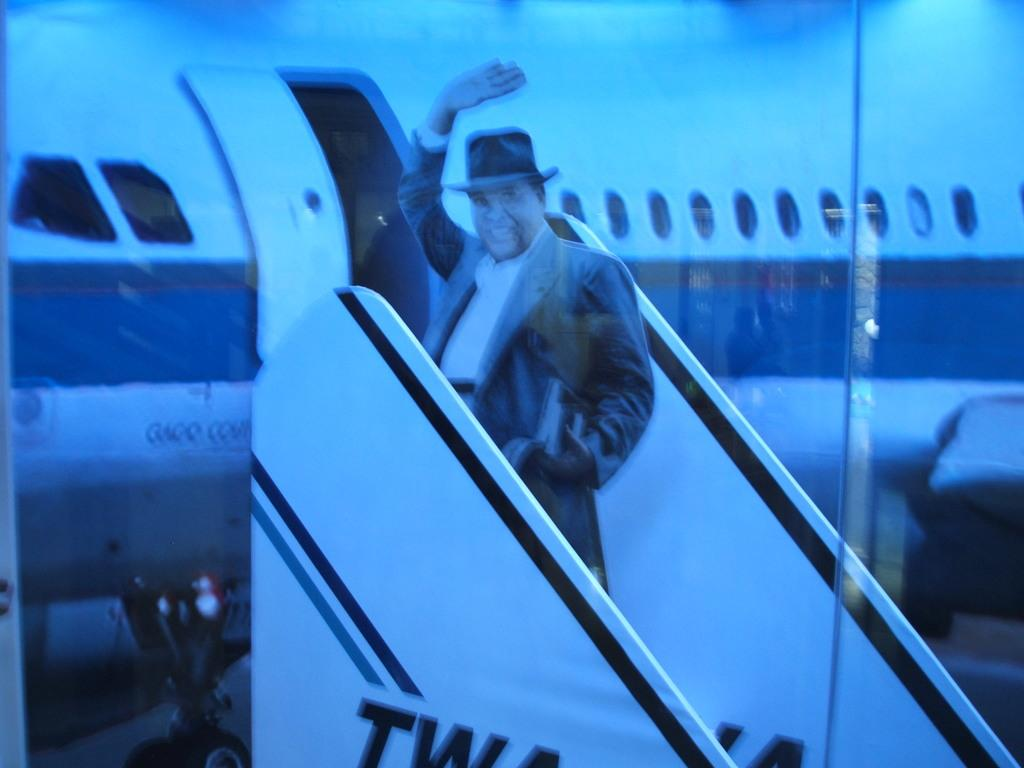What is the man in the image doing? The man is standing on the stairs in the image. Can you describe the stairs in the image? There is a flight of stairs in the image. What can be seen in the background of the image? There is a white-colored airplane in the background of the image. What type of carriage is being pulled by the horse in the image? There is no horse or carriage present in the image; it features a man standing on stairs with a white-colored airplane in the background. 